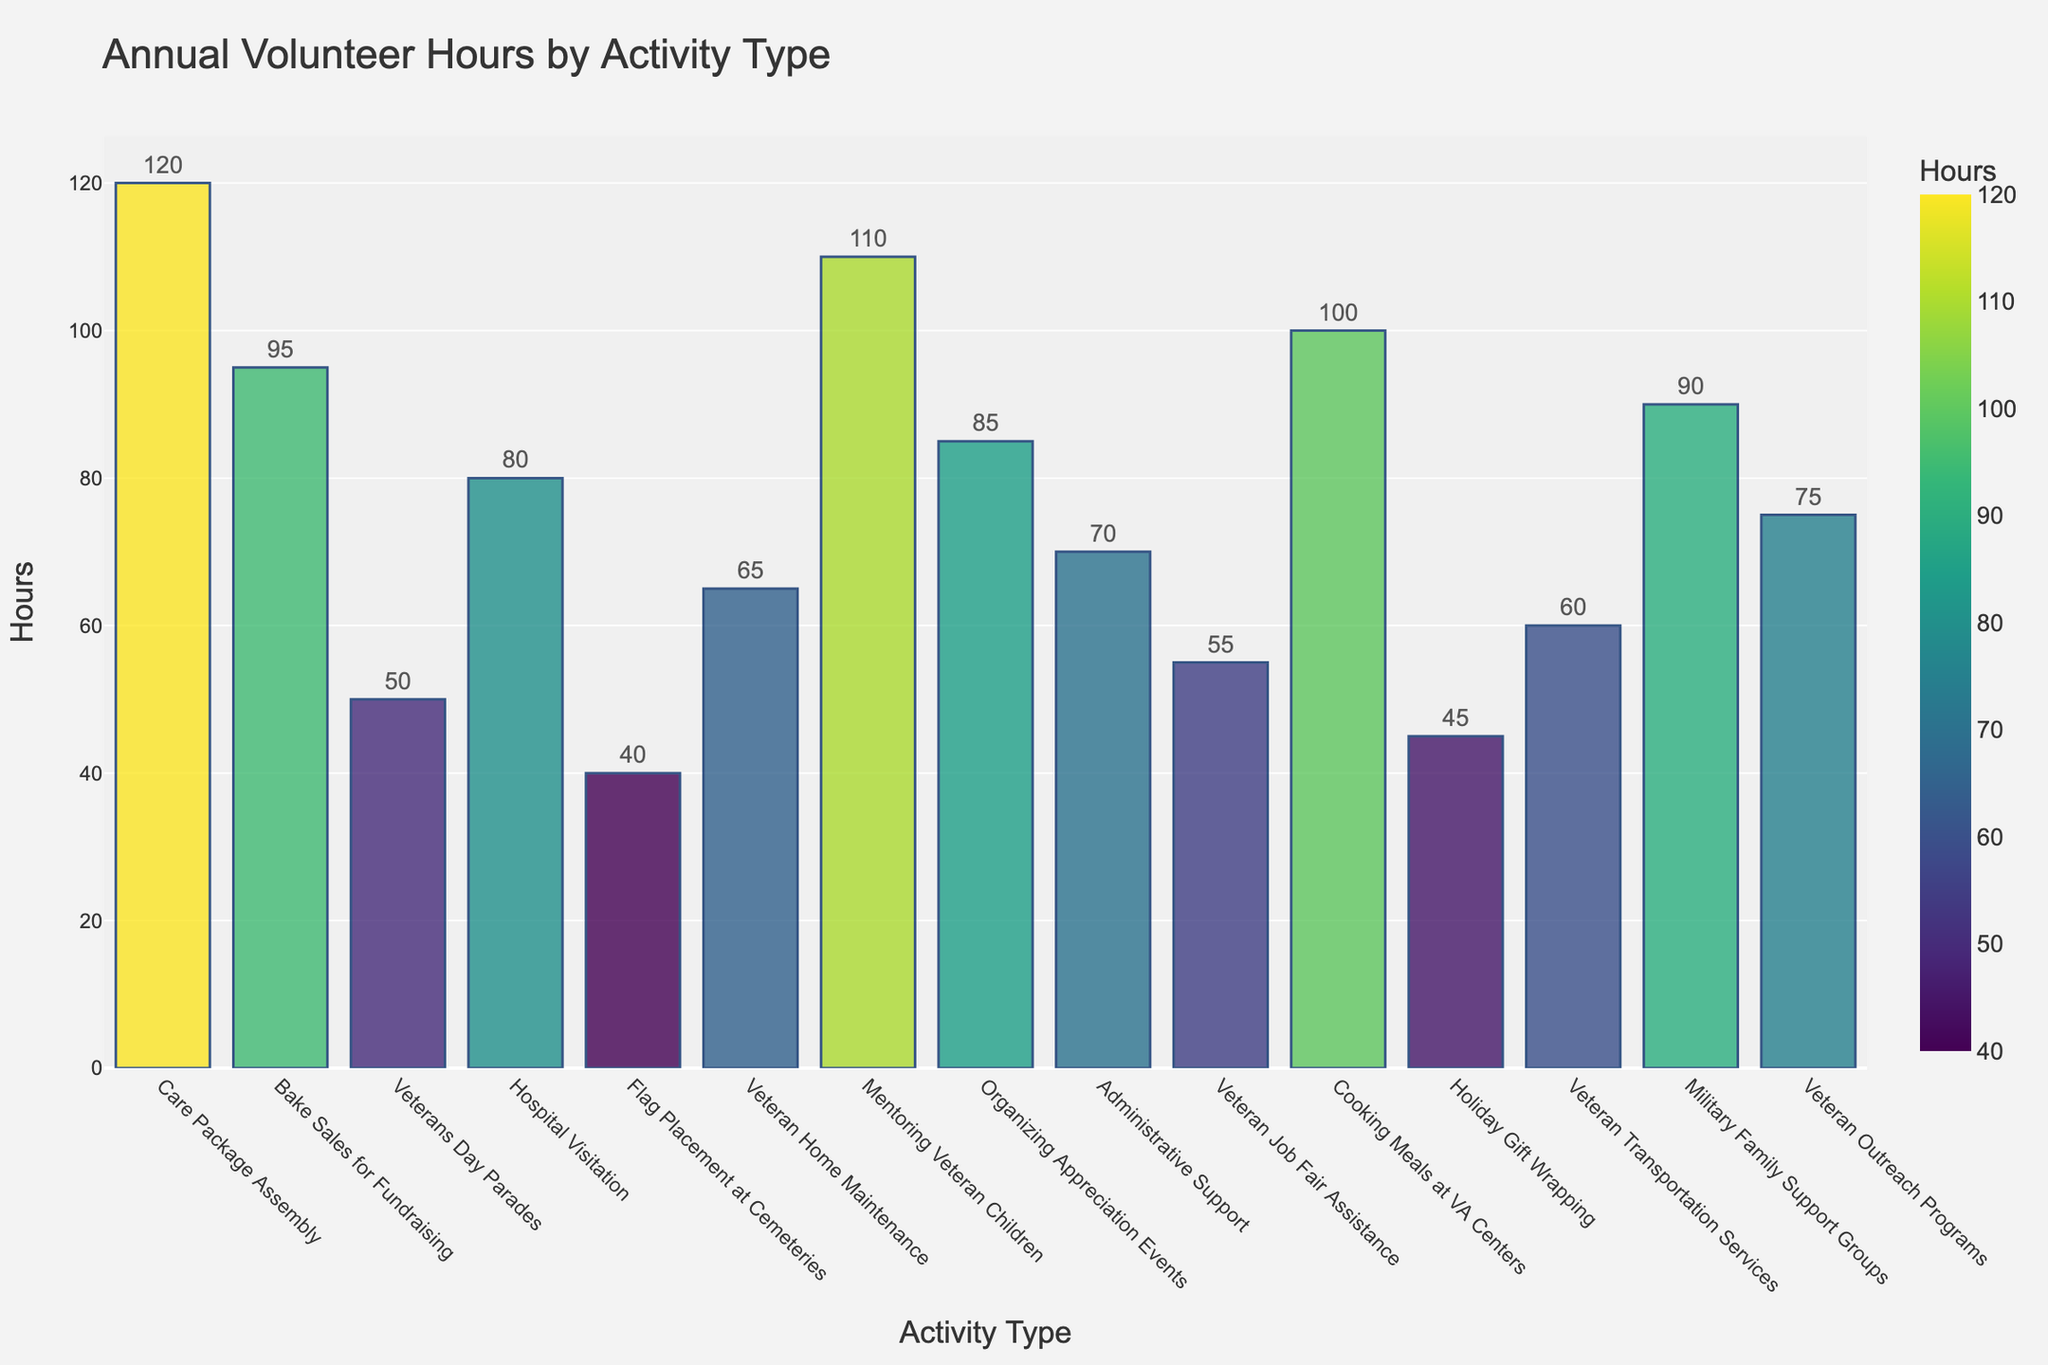Which activity type has the highest annual volunteer hours? Look for the tallest bar in the chart, which represents the activity type with the highest annual volunteer hours. The 'Care Package Assembly' bar is the tallest.
Answer: Care Package Assembly What is the sum of annual volunteer hours for 'Bake Sales for Fundraising' and 'Mentoring Veteran Children'? Add the annual hours for 'Bake Sales for Fundraising' (95 hours) and 'Mentoring Veteran Children' (110 hours). 95 + 110 = 205
Answer: 205 Which activity type has fewer annual volunteer hours: 'Veterans Day Parades' or 'Holiday Gift Wrapping'? Compare the heights of the bars for 'Veterans Day Parades' (50 hours) and 'Holiday Gift Wrapping' (45 hours). 'Holiday Gift Wrapping' is shorter.
Answer: Holiday Gift Wrapping How does 'Cooking Meals at VA Centers' compare to 'Veteran Transportation Services' in terms of volunteer hours? Compare the heights of the bars for 'Cooking Meals at VA Centers' (100 hours) and 'Veteran Transportation Services' (60 hours). The bar for 'Cooking Meals at VA Centers' is taller.
Answer: Cooking Meals at VA Centers is higher What is the difference in annual volunteer hours between 'Organizing Appreciation Events' and 'Administrative Support'? Subtract the annual hours for 'Administrative Support' (70 hours) from 'Organizing Appreciation Events' (85 hours). 85 - 70 = 15
Answer: 15 Which activity type falls in the middle range of annual volunteer hours on the list? Identify which activity's bar is roughly in the middle when sorted by height. 'Hospital Visitation' with 80 hours falls around the middle.
Answer: Hospital Visitation What is the average annual volunteer hours contributed to 'Military Family Support Groups' and 'Veteran Outreach Programs'? Add the hours for 'Military Family Support Groups' (90 hours) and 'Veteran Outreach Programs' (75 hours) and divide by 2. (90 + 75) / 2 = 82.5
Answer: 82.5 Which activity type has the closest annual volunteer hours to 'Veteran Job Fair Assistance'? Identify bars close in height to 'Veteran Job Fair Assistance' (55 hours). 'Flag Placement at Cemeteries' with 40 hours and 'Veteran Transportation Services' with 60 hours are close, and 'Veteran Transportation Services' is the closest.
Answer: Veteran Transportation Services 